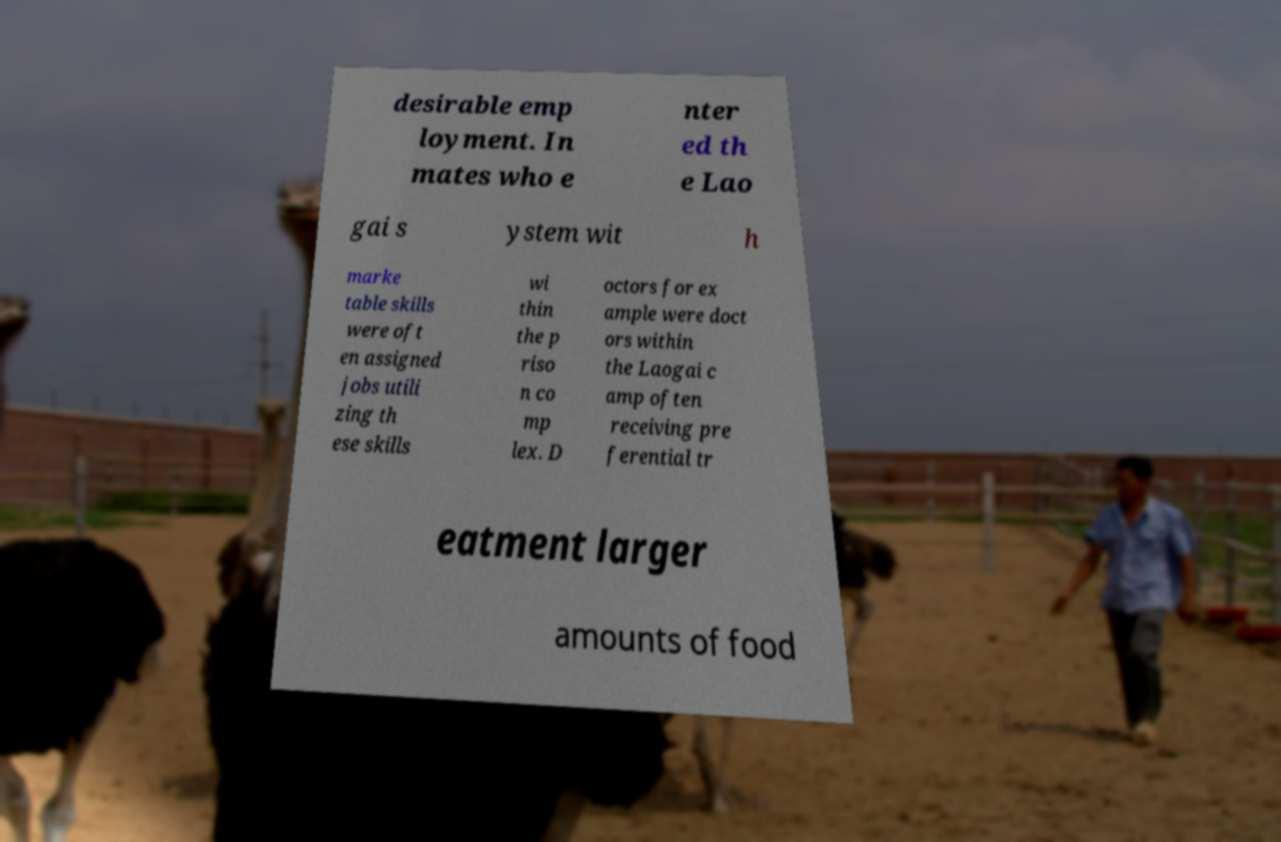What messages or text are displayed in this image? I need them in a readable, typed format. desirable emp loyment. In mates who e nter ed th e Lao gai s ystem wit h marke table skills were oft en assigned jobs utili zing th ese skills wi thin the p riso n co mp lex. D octors for ex ample were doct ors within the Laogai c amp often receiving pre ferential tr eatment larger amounts of food 